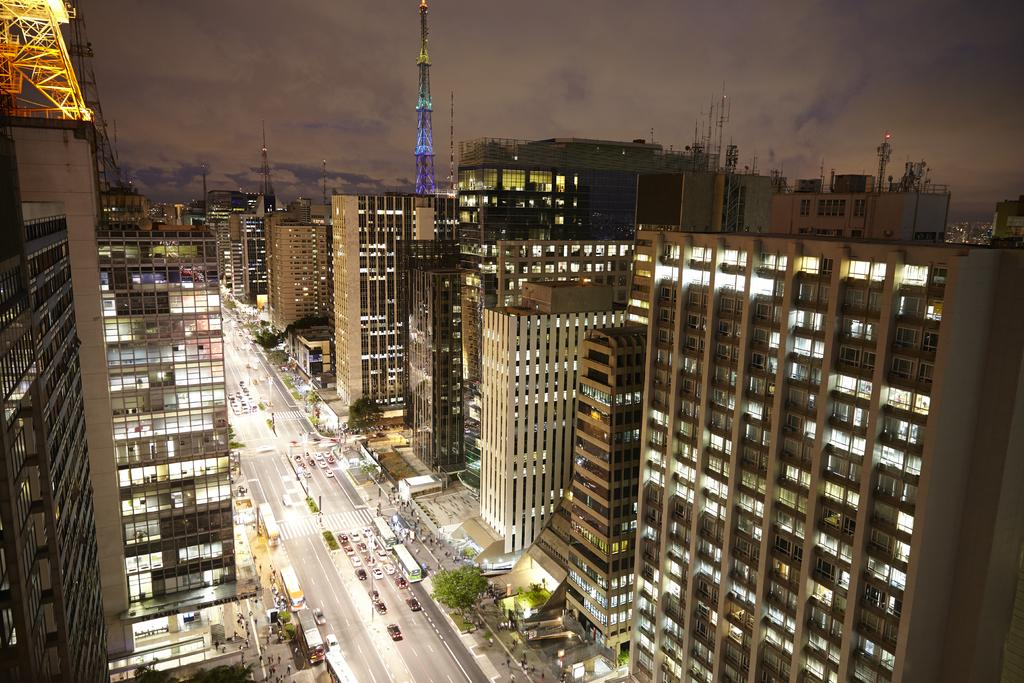What type of structures can be seen in the image? There are buildings and towers in the image. What is the purpose of the road in the image? The road is likely used for transportation in the image. What are the vehicles in the image used for? The vehicles in the image are likely used for transportation as well. What type of vegetation is present in the image? Trees are present in the image. What can be used for illumination in the image? Lights are visible in the image for illumination. Who or what is present in the image? There are people in the image. What is visible in the background of the image? The sky is visible in the image. What type of wool is being spun by the people in the image? There is no wool or spinning activity present in the image. What type of arch can be seen in the image? There is no arch present in the image. 